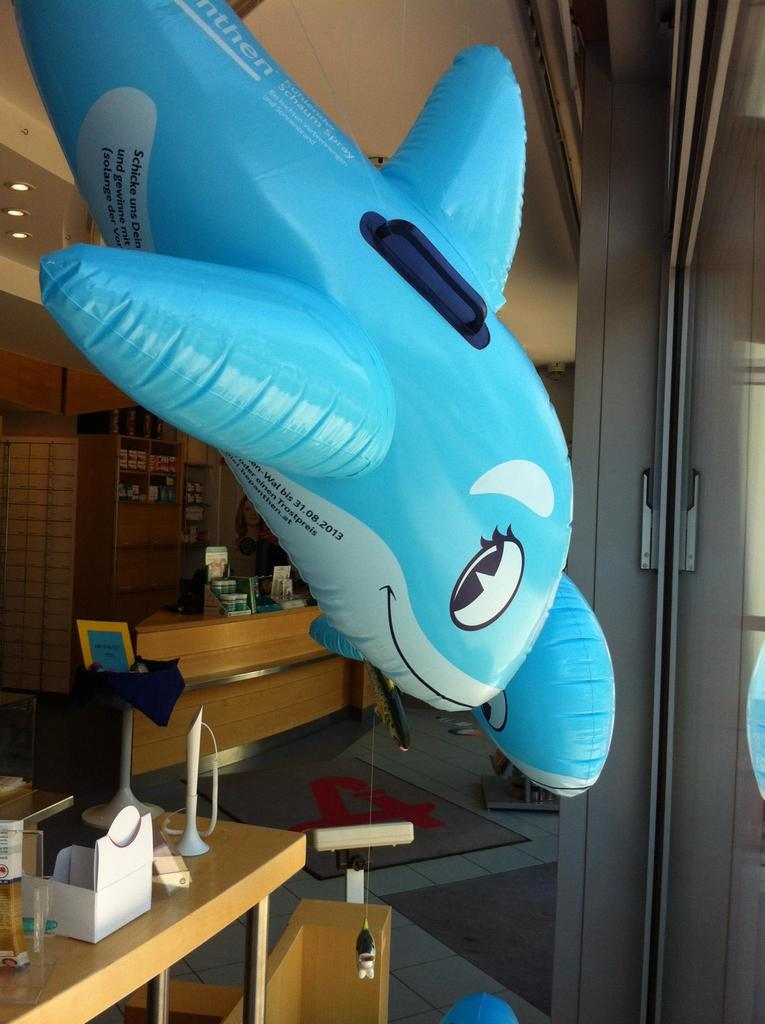<image>
Provide a brief description of the given image. Toy animals and a living room decoration, which has the date on the toy that says 31.08.2013 